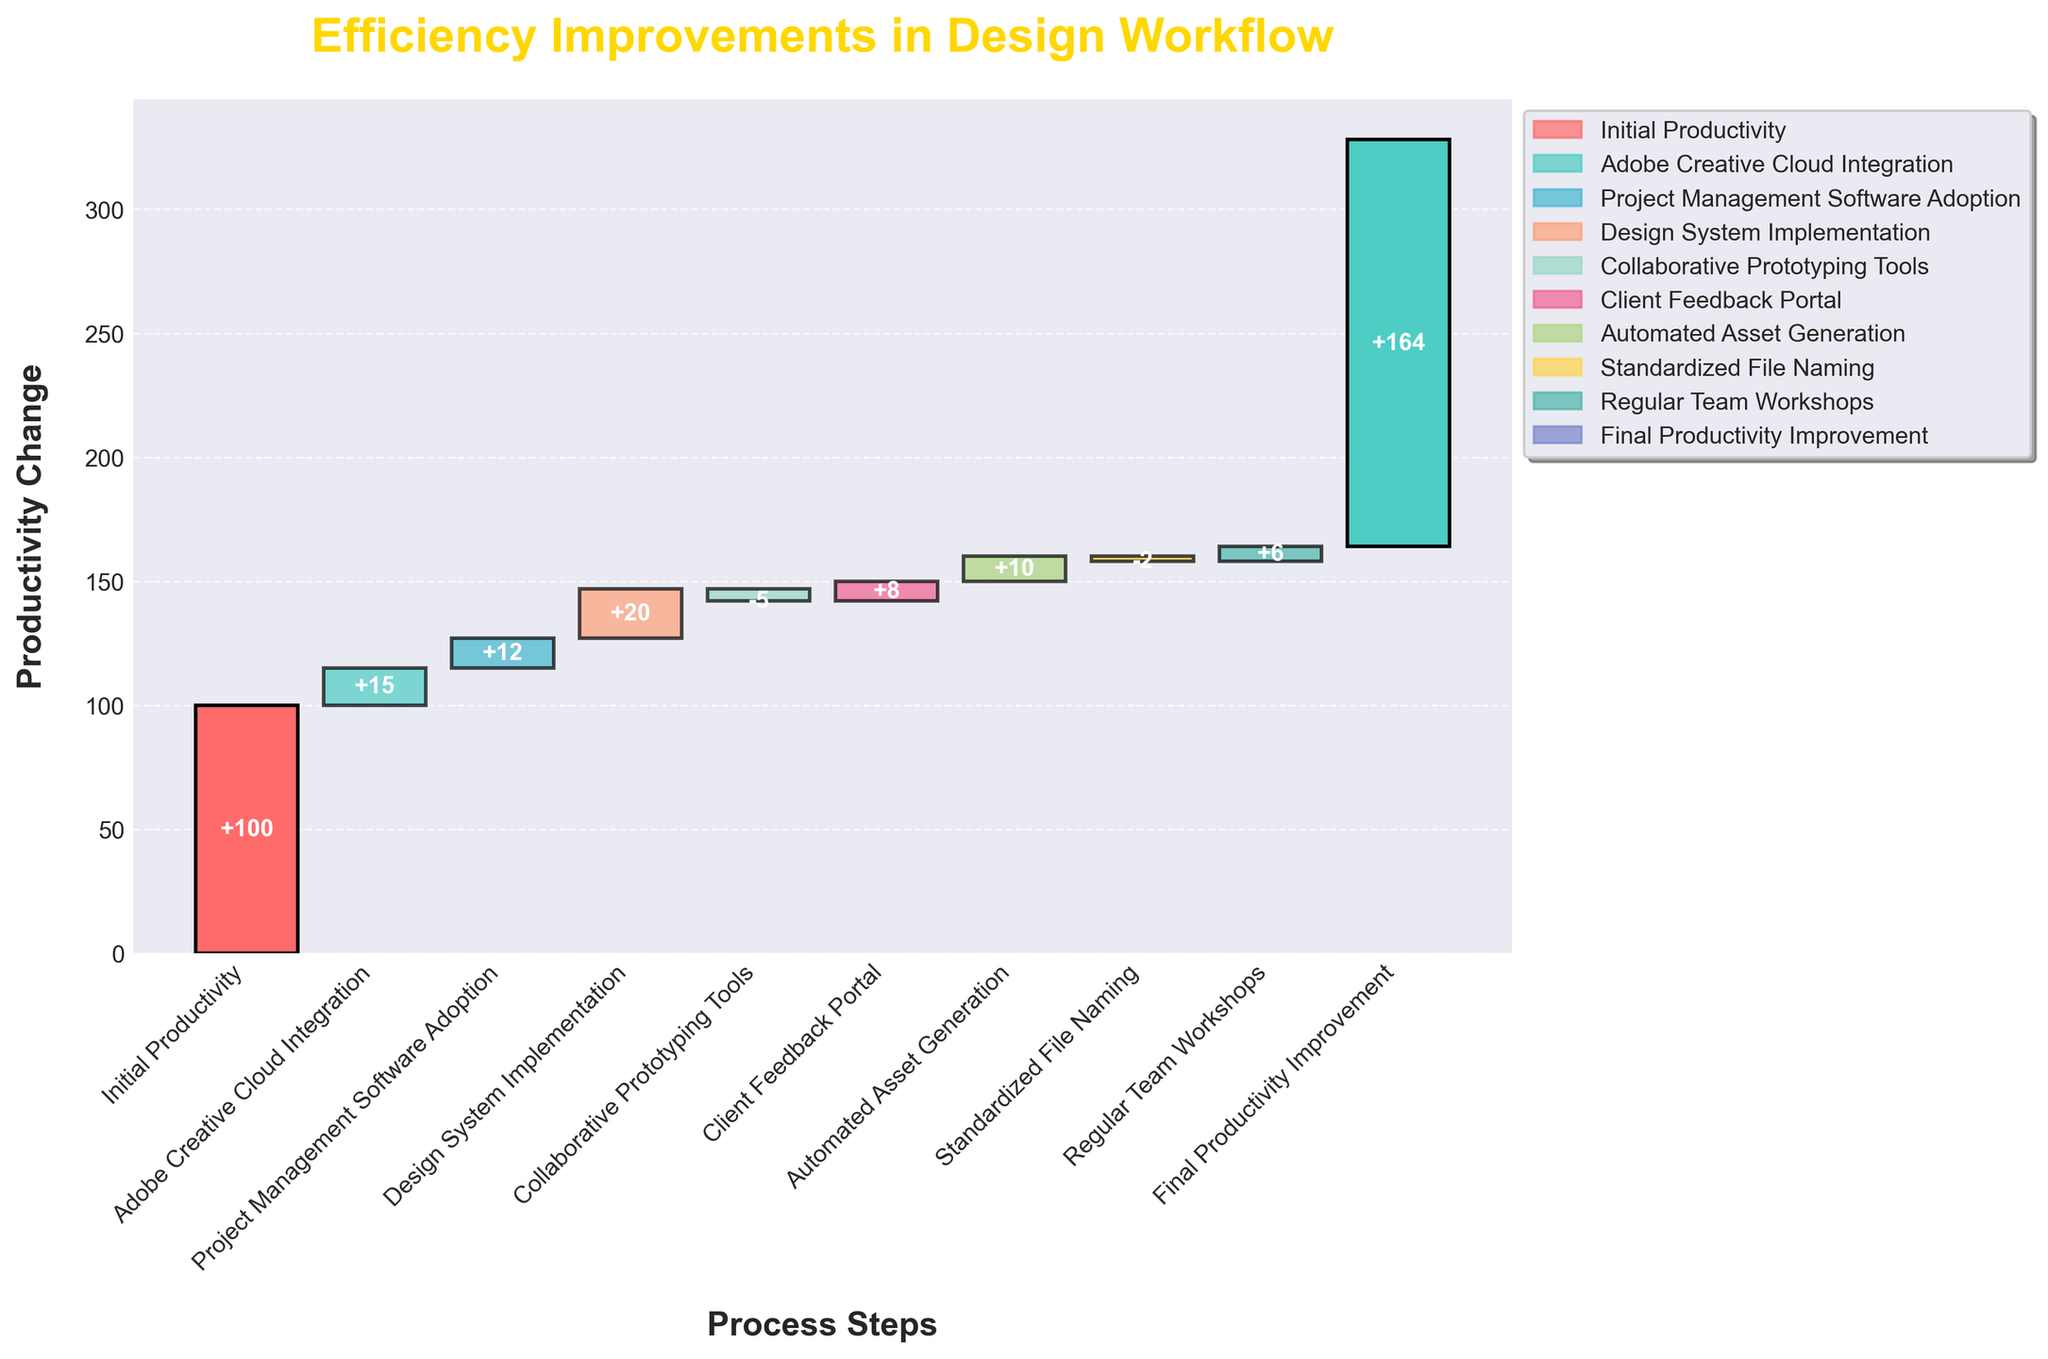What is the title of the chart? The title of the chart is located at the top of the figure and is styled in bold with a distinctive yellow color.
Answer: Efficiency Improvements in Design Workflow What is the initial productivity value? The initial productivity value is the first data point on the left side of the chart. It is labeled as "Initial Productivity" and corresponds to a value of 100.
Answer: 100 Which process step contributes the most positively to productivity? To determine which step contributes the most positively, look for the tallest positive bar in the chart. The "Design System Implementation" has the highest positive value of 20.
Answer: Design System Implementation How many process steps result in a decrease in productivity? Review the chart to count the bars that extend downward because they represent negative values. There are two such steps: "Collaborative Prototyping Tools" (-5) and "Standardized File Naming" (-2).
Answer: 2 What is the net productivity improvement after all steps are considered? The final bar on the right side of the chart represents the net productivity improvement. It indicates a value of 164.
Answer: 164 What is the combined impact of "Adobe Creative Cloud Integration" and "Project Management Software Adoption" on productivity? Add the values of the two steps: 15 (Adobe Creative Cloud Integration) + 12 (Project Management Software Adoption) = 27.
Answer: 27 Which two process steps have negative impacts on productivity? Identify the steps with downward bars. "Collaborative Prototyping Tools" has a value of -5 and "Standardized File Naming" has a value of -2.
Answer: Collaborative Prototyping Tools and Standardized File Naming How does the impact of "Client Feedback Portal" compare to "Automated Asset Generation"? Compare the bars for the two steps. "Client Feedback Portal" has a value of 8, and "Automated Asset Generation" has a value of 10. Thus, "Automated Asset Generation" has a slightly higher positive impact.
Answer: Automated Asset Generation is higher What is the sum of the productivity changes attributed to process steps with negative values? Sum the values of the negative steps: -5 (Collaborative Prototyping Tools) + (-2) (Standardized File Naming) = -7.
Answer: -7 What are the colors of the first and final process steps' bars in the chart? The first bar ("Initial Productivity") is colored red, and the final bar ("Final Productivity Improvement") is teal.
Answer: Red and Teal 